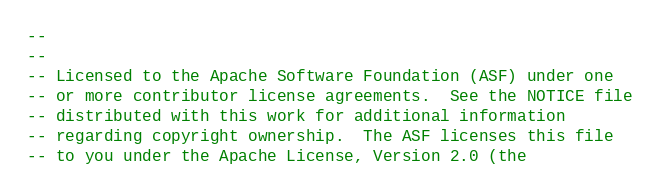<code> <loc_0><loc_0><loc_500><loc_500><_SQL_>--
--
-- Licensed to the Apache Software Foundation (ASF) under one
-- or more contributor license agreements.  See the NOTICE file
-- distributed with this work for additional information
-- regarding copyright ownership.  The ASF licenses this file
-- to you under the Apache License, Version 2.0 (the</code> 